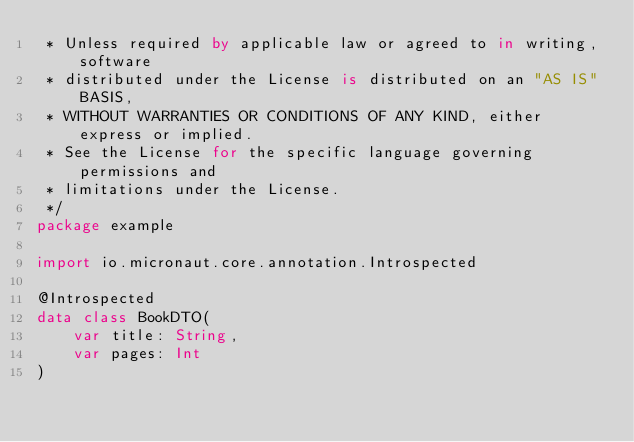Convert code to text. <code><loc_0><loc_0><loc_500><loc_500><_Kotlin_> * Unless required by applicable law or agreed to in writing, software
 * distributed under the License is distributed on an "AS IS" BASIS,
 * WITHOUT WARRANTIES OR CONDITIONS OF ANY KIND, either express or implied.
 * See the License for the specific language governing permissions and
 * limitations under the License.
 */
package example

import io.micronaut.core.annotation.Introspected

@Introspected
data class BookDTO(
    var title: String,
    var pages: Int
)
</code> 